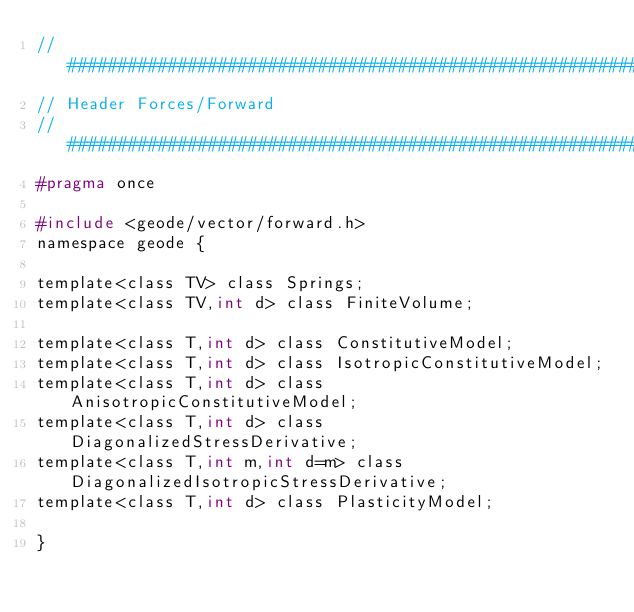Convert code to text. <code><loc_0><loc_0><loc_500><loc_500><_C_>//#####################################################################
// Header Forces/Forward
//#####################################################################
#pragma once

#include <geode/vector/forward.h>
namespace geode {

template<class TV> class Springs;
template<class TV,int d> class FiniteVolume;

template<class T,int d> class ConstitutiveModel;
template<class T,int d> class IsotropicConstitutiveModel;
template<class T,int d> class AnisotropicConstitutiveModel;
template<class T,int d> class DiagonalizedStressDerivative;
template<class T,int m,int d=m> class DiagonalizedIsotropicStressDerivative;
template<class T,int d> class PlasticityModel;

}
</code> 